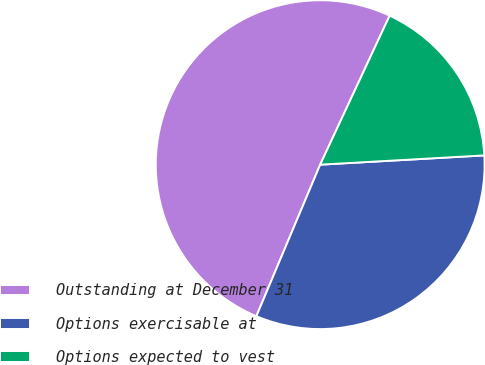<chart> <loc_0><loc_0><loc_500><loc_500><pie_chart><fcel>Outstanding at December 31<fcel>Options exercisable at<fcel>Options expected to vest<nl><fcel>50.6%<fcel>32.24%<fcel>17.16%<nl></chart> 